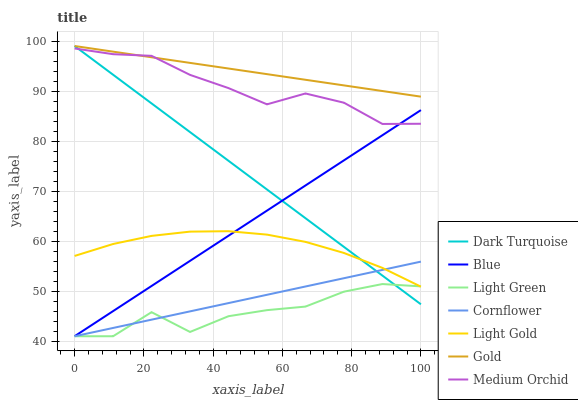Does Light Green have the minimum area under the curve?
Answer yes or no. Yes. Does Gold have the maximum area under the curve?
Answer yes or no. Yes. Does Cornflower have the minimum area under the curve?
Answer yes or no. No. Does Cornflower have the maximum area under the curve?
Answer yes or no. No. Is Cornflower the smoothest?
Answer yes or no. Yes. Is Light Green the roughest?
Answer yes or no. Yes. Is Gold the smoothest?
Answer yes or no. No. Is Gold the roughest?
Answer yes or no. No. Does Gold have the lowest value?
Answer yes or no. No. Does Dark Turquoise have the highest value?
Answer yes or no. Yes. Does Cornflower have the highest value?
Answer yes or no. No. Is Cornflower less than Medium Orchid?
Answer yes or no. Yes. Is Gold greater than Cornflower?
Answer yes or no. Yes. Does Cornflower intersect Light Gold?
Answer yes or no. Yes. Is Cornflower less than Light Gold?
Answer yes or no. No. Is Cornflower greater than Light Gold?
Answer yes or no. No. Does Cornflower intersect Medium Orchid?
Answer yes or no. No. 